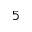<formula> <loc_0><loc_0><loc_500><loc_500>5</formula> 